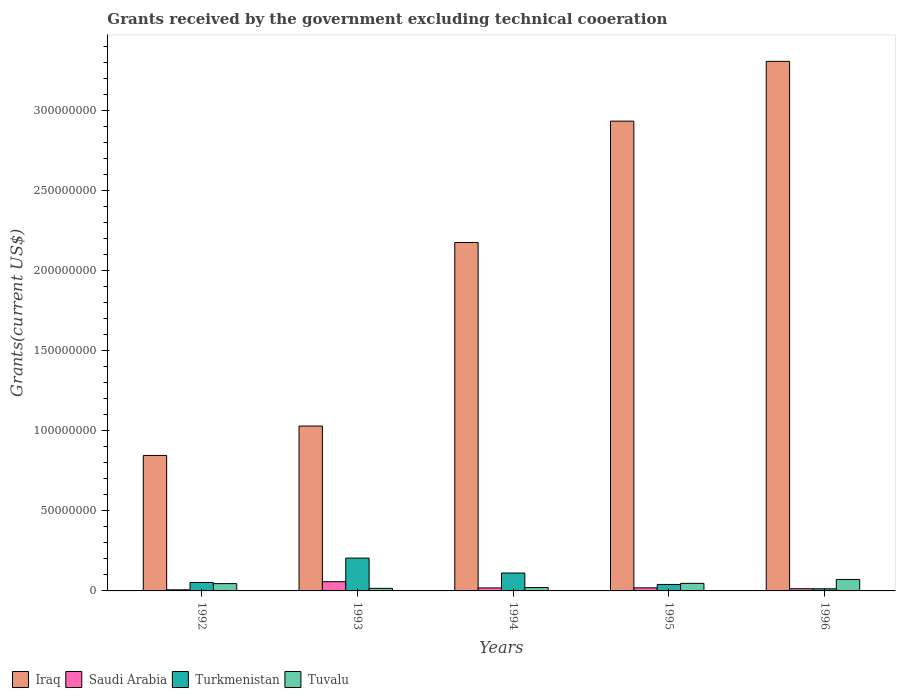Are the number of bars on each tick of the X-axis equal?
Provide a succinct answer. Yes. What is the label of the 1st group of bars from the left?
Your response must be concise. 1992. What is the total grants received by the government in Iraq in 1995?
Give a very brief answer. 2.94e+08. Across all years, what is the maximum total grants received by the government in Turkmenistan?
Offer a terse response. 2.05e+07. Across all years, what is the minimum total grants received by the government in Turkmenistan?
Your response must be concise. 1.32e+06. In which year was the total grants received by the government in Iraq minimum?
Provide a succinct answer. 1992. What is the total total grants received by the government in Saudi Arabia in the graph?
Offer a terse response. 1.16e+07. What is the difference between the total grants received by the government in Iraq in 1993 and that in 1995?
Provide a short and direct response. -1.91e+08. What is the difference between the total grants received by the government in Saudi Arabia in 1993 and the total grants received by the government in Iraq in 1995?
Provide a succinct answer. -2.88e+08. What is the average total grants received by the government in Tuvalu per year?
Your answer should be very brief. 4.03e+06. In the year 1995, what is the difference between the total grants received by the government in Tuvalu and total grants received by the government in Saudi Arabia?
Provide a succinct answer. 2.82e+06. What is the ratio of the total grants received by the government in Turkmenistan in 1992 to that in 1993?
Provide a short and direct response. 0.26. Is the total grants received by the government in Tuvalu in 1993 less than that in 1994?
Make the answer very short. Yes. What is the difference between the highest and the second highest total grants received by the government in Iraq?
Keep it short and to the point. 3.74e+07. What is the difference between the highest and the lowest total grants received by the government in Tuvalu?
Keep it short and to the point. 5.56e+06. In how many years, is the total grants received by the government in Tuvalu greater than the average total grants received by the government in Tuvalu taken over all years?
Your response must be concise. 3. Is the sum of the total grants received by the government in Tuvalu in 1995 and 1996 greater than the maximum total grants received by the government in Saudi Arabia across all years?
Your response must be concise. Yes. Is it the case that in every year, the sum of the total grants received by the government in Turkmenistan and total grants received by the government in Tuvalu is greater than the sum of total grants received by the government in Saudi Arabia and total grants received by the government in Iraq?
Give a very brief answer. Yes. What does the 4th bar from the left in 1996 represents?
Provide a succinct answer. Tuvalu. What does the 4th bar from the right in 1992 represents?
Offer a terse response. Iraq. Are all the bars in the graph horizontal?
Your answer should be compact. No. How many years are there in the graph?
Your answer should be very brief. 5. Are the values on the major ticks of Y-axis written in scientific E-notation?
Ensure brevity in your answer.  No. Does the graph contain grids?
Keep it short and to the point. No. Where does the legend appear in the graph?
Provide a succinct answer. Bottom left. What is the title of the graph?
Your answer should be very brief. Grants received by the government excluding technical cooeration. What is the label or title of the Y-axis?
Your answer should be very brief. Grants(current US$). What is the Grants(current US$) of Iraq in 1992?
Give a very brief answer. 8.47e+07. What is the Grants(current US$) of Saudi Arabia in 1992?
Your answer should be very brief. 6.90e+05. What is the Grants(current US$) of Turkmenistan in 1992?
Your answer should be very brief. 5.28e+06. What is the Grants(current US$) of Tuvalu in 1992?
Provide a short and direct response. 4.56e+06. What is the Grants(current US$) in Iraq in 1993?
Give a very brief answer. 1.03e+08. What is the Grants(current US$) of Saudi Arabia in 1993?
Your answer should be compact. 5.78e+06. What is the Grants(current US$) of Turkmenistan in 1993?
Provide a short and direct response. 2.05e+07. What is the Grants(current US$) in Tuvalu in 1993?
Give a very brief answer. 1.61e+06. What is the Grants(current US$) in Iraq in 1994?
Your answer should be very brief. 2.18e+08. What is the Grants(current US$) of Saudi Arabia in 1994?
Ensure brevity in your answer.  1.88e+06. What is the Grants(current US$) in Turkmenistan in 1994?
Your answer should be very brief. 1.12e+07. What is the Grants(current US$) of Tuvalu in 1994?
Your answer should be compact. 2.10e+06. What is the Grants(current US$) of Iraq in 1995?
Your response must be concise. 2.94e+08. What is the Grants(current US$) of Saudi Arabia in 1995?
Keep it short and to the point. 1.91e+06. What is the Grants(current US$) of Turkmenistan in 1995?
Offer a very short reply. 4.05e+06. What is the Grants(current US$) of Tuvalu in 1995?
Provide a short and direct response. 4.73e+06. What is the Grants(current US$) of Iraq in 1996?
Your answer should be very brief. 3.31e+08. What is the Grants(current US$) of Saudi Arabia in 1996?
Your answer should be compact. 1.36e+06. What is the Grants(current US$) in Turkmenistan in 1996?
Ensure brevity in your answer.  1.32e+06. What is the Grants(current US$) in Tuvalu in 1996?
Your answer should be very brief. 7.17e+06. Across all years, what is the maximum Grants(current US$) of Iraq?
Your response must be concise. 3.31e+08. Across all years, what is the maximum Grants(current US$) of Saudi Arabia?
Offer a very short reply. 5.78e+06. Across all years, what is the maximum Grants(current US$) in Turkmenistan?
Keep it short and to the point. 2.05e+07. Across all years, what is the maximum Grants(current US$) in Tuvalu?
Your response must be concise. 7.17e+06. Across all years, what is the minimum Grants(current US$) of Iraq?
Offer a very short reply. 8.47e+07. Across all years, what is the minimum Grants(current US$) of Saudi Arabia?
Provide a short and direct response. 6.90e+05. Across all years, what is the minimum Grants(current US$) in Turkmenistan?
Your answer should be very brief. 1.32e+06. Across all years, what is the minimum Grants(current US$) in Tuvalu?
Your answer should be very brief. 1.61e+06. What is the total Grants(current US$) in Iraq in the graph?
Your response must be concise. 1.03e+09. What is the total Grants(current US$) of Saudi Arabia in the graph?
Make the answer very short. 1.16e+07. What is the total Grants(current US$) of Turkmenistan in the graph?
Provide a short and direct response. 4.24e+07. What is the total Grants(current US$) in Tuvalu in the graph?
Offer a very short reply. 2.02e+07. What is the difference between the Grants(current US$) in Iraq in 1992 and that in 1993?
Your answer should be compact. -1.84e+07. What is the difference between the Grants(current US$) in Saudi Arabia in 1992 and that in 1993?
Ensure brevity in your answer.  -5.09e+06. What is the difference between the Grants(current US$) of Turkmenistan in 1992 and that in 1993?
Offer a very short reply. -1.52e+07. What is the difference between the Grants(current US$) of Tuvalu in 1992 and that in 1993?
Provide a succinct answer. 2.95e+06. What is the difference between the Grants(current US$) of Iraq in 1992 and that in 1994?
Your answer should be compact. -1.33e+08. What is the difference between the Grants(current US$) of Saudi Arabia in 1992 and that in 1994?
Keep it short and to the point. -1.19e+06. What is the difference between the Grants(current US$) in Turkmenistan in 1992 and that in 1994?
Your response must be concise. -5.91e+06. What is the difference between the Grants(current US$) of Tuvalu in 1992 and that in 1994?
Offer a very short reply. 2.46e+06. What is the difference between the Grants(current US$) in Iraq in 1992 and that in 1995?
Ensure brevity in your answer.  -2.09e+08. What is the difference between the Grants(current US$) in Saudi Arabia in 1992 and that in 1995?
Offer a terse response. -1.22e+06. What is the difference between the Grants(current US$) in Turkmenistan in 1992 and that in 1995?
Make the answer very short. 1.23e+06. What is the difference between the Grants(current US$) of Tuvalu in 1992 and that in 1995?
Offer a terse response. -1.70e+05. What is the difference between the Grants(current US$) in Iraq in 1992 and that in 1996?
Provide a short and direct response. -2.46e+08. What is the difference between the Grants(current US$) in Saudi Arabia in 1992 and that in 1996?
Your answer should be very brief. -6.70e+05. What is the difference between the Grants(current US$) of Turkmenistan in 1992 and that in 1996?
Keep it short and to the point. 3.96e+06. What is the difference between the Grants(current US$) in Tuvalu in 1992 and that in 1996?
Provide a succinct answer. -2.61e+06. What is the difference between the Grants(current US$) in Iraq in 1993 and that in 1994?
Make the answer very short. -1.15e+08. What is the difference between the Grants(current US$) of Saudi Arabia in 1993 and that in 1994?
Provide a short and direct response. 3.90e+06. What is the difference between the Grants(current US$) in Turkmenistan in 1993 and that in 1994?
Your answer should be very brief. 9.33e+06. What is the difference between the Grants(current US$) in Tuvalu in 1993 and that in 1994?
Provide a short and direct response. -4.90e+05. What is the difference between the Grants(current US$) of Iraq in 1993 and that in 1995?
Make the answer very short. -1.91e+08. What is the difference between the Grants(current US$) in Saudi Arabia in 1993 and that in 1995?
Provide a short and direct response. 3.87e+06. What is the difference between the Grants(current US$) of Turkmenistan in 1993 and that in 1995?
Make the answer very short. 1.65e+07. What is the difference between the Grants(current US$) in Tuvalu in 1993 and that in 1995?
Your answer should be very brief. -3.12e+06. What is the difference between the Grants(current US$) of Iraq in 1993 and that in 1996?
Offer a terse response. -2.28e+08. What is the difference between the Grants(current US$) of Saudi Arabia in 1993 and that in 1996?
Your answer should be very brief. 4.42e+06. What is the difference between the Grants(current US$) in Turkmenistan in 1993 and that in 1996?
Keep it short and to the point. 1.92e+07. What is the difference between the Grants(current US$) in Tuvalu in 1993 and that in 1996?
Provide a short and direct response. -5.56e+06. What is the difference between the Grants(current US$) in Iraq in 1994 and that in 1995?
Provide a short and direct response. -7.58e+07. What is the difference between the Grants(current US$) in Turkmenistan in 1994 and that in 1995?
Your answer should be very brief. 7.14e+06. What is the difference between the Grants(current US$) in Tuvalu in 1994 and that in 1995?
Ensure brevity in your answer.  -2.63e+06. What is the difference between the Grants(current US$) in Iraq in 1994 and that in 1996?
Ensure brevity in your answer.  -1.13e+08. What is the difference between the Grants(current US$) of Saudi Arabia in 1994 and that in 1996?
Make the answer very short. 5.20e+05. What is the difference between the Grants(current US$) of Turkmenistan in 1994 and that in 1996?
Your answer should be compact. 9.87e+06. What is the difference between the Grants(current US$) in Tuvalu in 1994 and that in 1996?
Make the answer very short. -5.07e+06. What is the difference between the Grants(current US$) in Iraq in 1995 and that in 1996?
Offer a very short reply. -3.74e+07. What is the difference between the Grants(current US$) in Saudi Arabia in 1995 and that in 1996?
Offer a terse response. 5.50e+05. What is the difference between the Grants(current US$) in Turkmenistan in 1995 and that in 1996?
Your answer should be very brief. 2.73e+06. What is the difference between the Grants(current US$) in Tuvalu in 1995 and that in 1996?
Your answer should be compact. -2.44e+06. What is the difference between the Grants(current US$) in Iraq in 1992 and the Grants(current US$) in Saudi Arabia in 1993?
Offer a very short reply. 7.89e+07. What is the difference between the Grants(current US$) of Iraq in 1992 and the Grants(current US$) of Turkmenistan in 1993?
Give a very brief answer. 6.42e+07. What is the difference between the Grants(current US$) of Iraq in 1992 and the Grants(current US$) of Tuvalu in 1993?
Your answer should be compact. 8.31e+07. What is the difference between the Grants(current US$) in Saudi Arabia in 1992 and the Grants(current US$) in Turkmenistan in 1993?
Provide a short and direct response. -1.98e+07. What is the difference between the Grants(current US$) of Saudi Arabia in 1992 and the Grants(current US$) of Tuvalu in 1993?
Your response must be concise. -9.20e+05. What is the difference between the Grants(current US$) of Turkmenistan in 1992 and the Grants(current US$) of Tuvalu in 1993?
Keep it short and to the point. 3.67e+06. What is the difference between the Grants(current US$) in Iraq in 1992 and the Grants(current US$) in Saudi Arabia in 1994?
Make the answer very short. 8.28e+07. What is the difference between the Grants(current US$) of Iraq in 1992 and the Grants(current US$) of Turkmenistan in 1994?
Ensure brevity in your answer.  7.35e+07. What is the difference between the Grants(current US$) of Iraq in 1992 and the Grants(current US$) of Tuvalu in 1994?
Offer a terse response. 8.26e+07. What is the difference between the Grants(current US$) of Saudi Arabia in 1992 and the Grants(current US$) of Turkmenistan in 1994?
Provide a short and direct response. -1.05e+07. What is the difference between the Grants(current US$) in Saudi Arabia in 1992 and the Grants(current US$) in Tuvalu in 1994?
Your response must be concise. -1.41e+06. What is the difference between the Grants(current US$) in Turkmenistan in 1992 and the Grants(current US$) in Tuvalu in 1994?
Ensure brevity in your answer.  3.18e+06. What is the difference between the Grants(current US$) of Iraq in 1992 and the Grants(current US$) of Saudi Arabia in 1995?
Provide a short and direct response. 8.28e+07. What is the difference between the Grants(current US$) in Iraq in 1992 and the Grants(current US$) in Turkmenistan in 1995?
Your answer should be very brief. 8.06e+07. What is the difference between the Grants(current US$) of Iraq in 1992 and the Grants(current US$) of Tuvalu in 1995?
Offer a terse response. 8.00e+07. What is the difference between the Grants(current US$) in Saudi Arabia in 1992 and the Grants(current US$) in Turkmenistan in 1995?
Your answer should be compact. -3.36e+06. What is the difference between the Grants(current US$) of Saudi Arabia in 1992 and the Grants(current US$) of Tuvalu in 1995?
Offer a terse response. -4.04e+06. What is the difference between the Grants(current US$) in Iraq in 1992 and the Grants(current US$) in Saudi Arabia in 1996?
Provide a succinct answer. 8.33e+07. What is the difference between the Grants(current US$) in Iraq in 1992 and the Grants(current US$) in Turkmenistan in 1996?
Provide a short and direct response. 8.34e+07. What is the difference between the Grants(current US$) of Iraq in 1992 and the Grants(current US$) of Tuvalu in 1996?
Offer a very short reply. 7.75e+07. What is the difference between the Grants(current US$) of Saudi Arabia in 1992 and the Grants(current US$) of Turkmenistan in 1996?
Offer a very short reply. -6.30e+05. What is the difference between the Grants(current US$) in Saudi Arabia in 1992 and the Grants(current US$) in Tuvalu in 1996?
Keep it short and to the point. -6.48e+06. What is the difference between the Grants(current US$) in Turkmenistan in 1992 and the Grants(current US$) in Tuvalu in 1996?
Offer a terse response. -1.89e+06. What is the difference between the Grants(current US$) in Iraq in 1993 and the Grants(current US$) in Saudi Arabia in 1994?
Provide a succinct answer. 1.01e+08. What is the difference between the Grants(current US$) of Iraq in 1993 and the Grants(current US$) of Turkmenistan in 1994?
Provide a succinct answer. 9.19e+07. What is the difference between the Grants(current US$) in Iraq in 1993 and the Grants(current US$) in Tuvalu in 1994?
Keep it short and to the point. 1.01e+08. What is the difference between the Grants(current US$) in Saudi Arabia in 1993 and the Grants(current US$) in Turkmenistan in 1994?
Your answer should be very brief. -5.41e+06. What is the difference between the Grants(current US$) in Saudi Arabia in 1993 and the Grants(current US$) in Tuvalu in 1994?
Ensure brevity in your answer.  3.68e+06. What is the difference between the Grants(current US$) in Turkmenistan in 1993 and the Grants(current US$) in Tuvalu in 1994?
Ensure brevity in your answer.  1.84e+07. What is the difference between the Grants(current US$) in Iraq in 1993 and the Grants(current US$) in Saudi Arabia in 1995?
Provide a succinct answer. 1.01e+08. What is the difference between the Grants(current US$) in Iraq in 1993 and the Grants(current US$) in Turkmenistan in 1995?
Your answer should be compact. 9.90e+07. What is the difference between the Grants(current US$) in Iraq in 1993 and the Grants(current US$) in Tuvalu in 1995?
Provide a succinct answer. 9.83e+07. What is the difference between the Grants(current US$) in Saudi Arabia in 1993 and the Grants(current US$) in Turkmenistan in 1995?
Offer a very short reply. 1.73e+06. What is the difference between the Grants(current US$) in Saudi Arabia in 1993 and the Grants(current US$) in Tuvalu in 1995?
Give a very brief answer. 1.05e+06. What is the difference between the Grants(current US$) of Turkmenistan in 1993 and the Grants(current US$) of Tuvalu in 1995?
Offer a very short reply. 1.58e+07. What is the difference between the Grants(current US$) in Iraq in 1993 and the Grants(current US$) in Saudi Arabia in 1996?
Make the answer very short. 1.02e+08. What is the difference between the Grants(current US$) of Iraq in 1993 and the Grants(current US$) of Turkmenistan in 1996?
Provide a short and direct response. 1.02e+08. What is the difference between the Grants(current US$) in Iraq in 1993 and the Grants(current US$) in Tuvalu in 1996?
Provide a succinct answer. 9.59e+07. What is the difference between the Grants(current US$) in Saudi Arabia in 1993 and the Grants(current US$) in Turkmenistan in 1996?
Provide a short and direct response. 4.46e+06. What is the difference between the Grants(current US$) of Saudi Arabia in 1993 and the Grants(current US$) of Tuvalu in 1996?
Your answer should be very brief. -1.39e+06. What is the difference between the Grants(current US$) of Turkmenistan in 1993 and the Grants(current US$) of Tuvalu in 1996?
Offer a terse response. 1.34e+07. What is the difference between the Grants(current US$) of Iraq in 1994 and the Grants(current US$) of Saudi Arabia in 1995?
Your answer should be very brief. 2.16e+08. What is the difference between the Grants(current US$) in Iraq in 1994 and the Grants(current US$) in Turkmenistan in 1995?
Your answer should be compact. 2.14e+08. What is the difference between the Grants(current US$) in Iraq in 1994 and the Grants(current US$) in Tuvalu in 1995?
Provide a succinct answer. 2.13e+08. What is the difference between the Grants(current US$) of Saudi Arabia in 1994 and the Grants(current US$) of Turkmenistan in 1995?
Make the answer very short. -2.17e+06. What is the difference between the Grants(current US$) in Saudi Arabia in 1994 and the Grants(current US$) in Tuvalu in 1995?
Provide a succinct answer. -2.85e+06. What is the difference between the Grants(current US$) of Turkmenistan in 1994 and the Grants(current US$) of Tuvalu in 1995?
Provide a short and direct response. 6.46e+06. What is the difference between the Grants(current US$) in Iraq in 1994 and the Grants(current US$) in Saudi Arabia in 1996?
Your response must be concise. 2.16e+08. What is the difference between the Grants(current US$) in Iraq in 1994 and the Grants(current US$) in Turkmenistan in 1996?
Your response must be concise. 2.16e+08. What is the difference between the Grants(current US$) in Iraq in 1994 and the Grants(current US$) in Tuvalu in 1996?
Offer a terse response. 2.11e+08. What is the difference between the Grants(current US$) of Saudi Arabia in 1994 and the Grants(current US$) of Turkmenistan in 1996?
Ensure brevity in your answer.  5.60e+05. What is the difference between the Grants(current US$) in Saudi Arabia in 1994 and the Grants(current US$) in Tuvalu in 1996?
Provide a short and direct response. -5.29e+06. What is the difference between the Grants(current US$) in Turkmenistan in 1994 and the Grants(current US$) in Tuvalu in 1996?
Offer a very short reply. 4.02e+06. What is the difference between the Grants(current US$) of Iraq in 1995 and the Grants(current US$) of Saudi Arabia in 1996?
Offer a terse response. 2.92e+08. What is the difference between the Grants(current US$) of Iraq in 1995 and the Grants(current US$) of Turkmenistan in 1996?
Make the answer very short. 2.92e+08. What is the difference between the Grants(current US$) of Iraq in 1995 and the Grants(current US$) of Tuvalu in 1996?
Your response must be concise. 2.86e+08. What is the difference between the Grants(current US$) of Saudi Arabia in 1995 and the Grants(current US$) of Turkmenistan in 1996?
Make the answer very short. 5.90e+05. What is the difference between the Grants(current US$) in Saudi Arabia in 1995 and the Grants(current US$) in Tuvalu in 1996?
Your answer should be compact. -5.26e+06. What is the difference between the Grants(current US$) of Turkmenistan in 1995 and the Grants(current US$) of Tuvalu in 1996?
Offer a very short reply. -3.12e+06. What is the average Grants(current US$) in Iraq per year?
Your response must be concise. 2.06e+08. What is the average Grants(current US$) in Saudi Arabia per year?
Make the answer very short. 2.32e+06. What is the average Grants(current US$) of Turkmenistan per year?
Offer a very short reply. 8.47e+06. What is the average Grants(current US$) of Tuvalu per year?
Make the answer very short. 4.03e+06. In the year 1992, what is the difference between the Grants(current US$) in Iraq and Grants(current US$) in Saudi Arabia?
Provide a short and direct response. 8.40e+07. In the year 1992, what is the difference between the Grants(current US$) of Iraq and Grants(current US$) of Turkmenistan?
Provide a short and direct response. 7.94e+07. In the year 1992, what is the difference between the Grants(current US$) of Iraq and Grants(current US$) of Tuvalu?
Your answer should be compact. 8.01e+07. In the year 1992, what is the difference between the Grants(current US$) in Saudi Arabia and Grants(current US$) in Turkmenistan?
Offer a terse response. -4.59e+06. In the year 1992, what is the difference between the Grants(current US$) in Saudi Arabia and Grants(current US$) in Tuvalu?
Your response must be concise. -3.87e+06. In the year 1992, what is the difference between the Grants(current US$) in Turkmenistan and Grants(current US$) in Tuvalu?
Offer a terse response. 7.20e+05. In the year 1993, what is the difference between the Grants(current US$) in Iraq and Grants(current US$) in Saudi Arabia?
Your answer should be compact. 9.73e+07. In the year 1993, what is the difference between the Grants(current US$) in Iraq and Grants(current US$) in Turkmenistan?
Keep it short and to the point. 8.25e+07. In the year 1993, what is the difference between the Grants(current US$) in Iraq and Grants(current US$) in Tuvalu?
Your response must be concise. 1.01e+08. In the year 1993, what is the difference between the Grants(current US$) of Saudi Arabia and Grants(current US$) of Turkmenistan?
Provide a succinct answer. -1.47e+07. In the year 1993, what is the difference between the Grants(current US$) in Saudi Arabia and Grants(current US$) in Tuvalu?
Offer a very short reply. 4.17e+06. In the year 1993, what is the difference between the Grants(current US$) in Turkmenistan and Grants(current US$) in Tuvalu?
Provide a short and direct response. 1.89e+07. In the year 1994, what is the difference between the Grants(current US$) in Iraq and Grants(current US$) in Saudi Arabia?
Keep it short and to the point. 2.16e+08. In the year 1994, what is the difference between the Grants(current US$) in Iraq and Grants(current US$) in Turkmenistan?
Provide a succinct answer. 2.07e+08. In the year 1994, what is the difference between the Grants(current US$) of Iraq and Grants(current US$) of Tuvalu?
Your response must be concise. 2.16e+08. In the year 1994, what is the difference between the Grants(current US$) in Saudi Arabia and Grants(current US$) in Turkmenistan?
Provide a succinct answer. -9.31e+06. In the year 1994, what is the difference between the Grants(current US$) of Saudi Arabia and Grants(current US$) of Tuvalu?
Your answer should be compact. -2.20e+05. In the year 1994, what is the difference between the Grants(current US$) in Turkmenistan and Grants(current US$) in Tuvalu?
Offer a very short reply. 9.09e+06. In the year 1995, what is the difference between the Grants(current US$) in Iraq and Grants(current US$) in Saudi Arabia?
Your answer should be very brief. 2.92e+08. In the year 1995, what is the difference between the Grants(current US$) in Iraq and Grants(current US$) in Turkmenistan?
Give a very brief answer. 2.90e+08. In the year 1995, what is the difference between the Grants(current US$) of Iraq and Grants(current US$) of Tuvalu?
Give a very brief answer. 2.89e+08. In the year 1995, what is the difference between the Grants(current US$) of Saudi Arabia and Grants(current US$) of Turkmenistan?
Your answer should be very brief. -2.14e+06. In the year 1995, what is the difference between the Grants(current US$) in Saudi Arabia and Grants(current US$) in Tuvalu?
Provide a succinct answer. -2.82e+06. In the year 1995, what is the difference between the Grants(current US$) of Turkmenistan and Grants(current US$) of Tuvalu?
Your response must be concise. -6.80e+05. In the year 1996, what is the difference between the Grants(current US$) of Iraq and Grants(current US$) of Saudi Arabia?
Offer a very short reply. 3.30e+08. In the year 1996, what is the difference between the Grants(current US$) of Iraq and Grants(current US$) of Turkmenistan?
Your answer should be very brief. 3.30e+08. In the year 1996, what is the difference between the Grants(current US$) of Iraq and Grants(current US$) of Tuvalu?
Offer a terse response. 3.24e+08. In the year 1996, what is the difference between the Grants(current US$) of Saudi Arabia and Grants(current US$) of Turkmenistan?
Your response must be concise. 4.00e+04. In the year 1996, what is the difference between the Grants(current US$) of Saudi Arabia and Grants(current US$) of Tuvalu?
Provide a succinct answer. -5.81e+06. In the year 1996, what is the difference between the Grants(current US$) in Turkmenistan and Grants(current US$) in Tuvalu?
Offer a very short reply. -5.85e+06. What is the ratio of the Grants(current US$) of Iraq in 1992 to that in 1993?
Your answer should be very brief. 0.82. What is the ratio of the Grants(current US$) in Saudi Arabia in 1992 to that in 1993?
Your answer should be compact. 0.12. What is the ratio of the Grants(current US$) in Turkmenistan in 1992 to that in 1993?
Keep it short and to the point. 0.26. What is the ratio of the Grants(current US$) of Tuvalu in 1992 to that in 1993?
Ensure brevity in your answer.  2.83. What is the ratio of the Grants(current US$) of Iraq in 1992 to that in 1994?
Ensure brevity in your answer.  0.39. What is the ratio of the Grants(current US$) of Saudi Arabia in 1992 to that in 1994?
Offer a very short reply. 0.37. What is the ratio of the Grants(current US$) of Turkmenistan in 1992 to that in 1994?
Give a very brief answer. 0.47. What is the ratio of the Grants(current US$) in Tuvalu in 1992 to that in 1994?
Your response must be concise. 2.17. What is the ratio of the Grants(current US$) of Iraq in 1992 to that in 1995?
Offer a very short reply. 0.29. What is the ratio of the Grants(current US$) of Saudi Arabia in 1992 to that in 1995?
Your answer should be very brief. 0.36. What is the ratio of the Grants(current US$) in Turkmenistan in 1992 to that in 1995?
Offer a terse response. 1.3. What is the ratio of the Grants(current US$) in Tuvalu in 1992 to that in 1995?
Offer a very short reply. 0.96. What is the ratio of the Grants(current US$) in Iraq in 1992 to that in 1996?
Offer a terse response. 0.26. What is the ratio of the Grants(current US$) of Saudi Arabia in 1992 to that in 1996?
Your response must be concise. 0.51. What is the ratio of the Grants(current US$) of Turkmenistan in 1992 to that in 1996?
Provide a succinct answer. 4. What is the ratio of the Grants(current US$) of Tuvalu in 1992 to that in 1996?
Provide a short and direct response. 0.64. What is the ratio of the Grants(current US$) of Iraq in 1993 to that in 1994?
Ensure brevity in your answer.  0.47. What is the ratio of the Grants(current US$) in Saudi Arabia in 1993 to that in 1994?
Keep it short and to the point. 3.07. What is the ratio of the Grants(current US$) in Turkmenistan in 1993 to that in 1994?
Your response must be concise. 1.83. What is the ratio of the Grants(current US$) in Tuvalu in 1993 to that in 1994?
Ensure brevity in your answer.  0.77. What is the ratio of the Grants(current US$) of Iraq in 1993 to that in 1995?
Make the answer very short. 0.35. What is the ratio of the Grants(current US$) of Saudi Arabia in 1993 to that in 1995?
Ensure brevity in your answer.  3.03. What is the ratio of the Grants(current US$) in Turkmenistan in 1993 to that in 1995?
Give a very brief answer. 5.07. What is the ratio of the Grants(current US$) in Tuvalu in 1993 to that in 1995?
Offer a terse response. 0.34. What is the ratio of the Grants(current US$) in Iraq in 1993 to that in 1996?
Offer a terse response. 0.31. What is the ratio of the Grants(current US$) of Saudi Arabia in 1993 to that in 1996?
Your response must be concise. 4.25. What is the ratio of the Grants(current US$) in Turkmenistan in 1993 to that in 1996?
Provide a short and direct response. 15.55. What is the ratio of the Grants(current US$) in Tuvalu in 1993 to that in 1996?
Provide a succinct answer. 0.22. What is the ratio of the Grants(current US$) in Iraq in 1994 to that in 1995?
Provide a short and direct response. 0.74. What is the ratio of the Grants(current US$) in Saudi Arabia in 1994 to that in 1995?
Ensure brevity in your answer.  0.98. What is the ratio of the Grants(current US$) in Turkmenistan in 1994 to that in 1995?
Your answer should be very brief. 2.76. What is the ratio of the Grants(current US$) in Tuvalu in 1994 to that in 1995?
Your answer should be very brief. 0.44. What is the ratio of the Grants(current US$) in Iraq in 1994 to that in 1996?
Keep it short and to the point. 0.66. What is the ratio of the Grants(current US$) of Saudi Arabia in 1994 to that in 1996?
Your answer should be compact. 1.38. What is the ratio of the Grants(current US$) of Turkmenistan in 1994 to that in 1996?
Your response must be concise. 8.48. What is the ratio of the Grants(current US$) of Tuvalu in 1994 to that in 1996?
Your answer should be compact. 0.29. What is the ratio of the Grants(current US$) in Iraq in 1995 to that in 1996?
Make the answer very short. 0.89. What is the ratio of the Grants(current US$) in Saudi Arabia in 1995 to that in 1996?
Ensure brevity in your answer.  1.4. What is the ratio of the Grants(current US$) of Turkmenistan in 1995 to that in 1996?
Offer a very short reply. 3.07. What is the ratio of the Grants(current US$) in Tuvalu in 1995 to that in 1996?
Your response must be concise. 0.66. What is the difference between the highest and the second highest Grants(current US$) in Iraq?
Provide a short and direct response. 3.74e+07. What is the difference between the highest and the second highest Grants(current US$) in Saudi Arabia?
Give a very brief answer. 3.87e+06. What is the difference between the highest and the second highest Grants(current US$) in Turkmenistan?
Offer a terse response. 9.33e+06. What is the difference between the highest and the second highest Grants(current US$) of Tuvalu?
Ensure brevity in your answer.  2.44e+06. What is the difference between the highest and the lowest Grants(current US$) of Iraq?
Make the answer very short. 2.46e+08. What is the difference between the highest and the lowest Grants(current US$) in Saudi Arabia?
Your answer should be compact. 5.09e+06. What is the difference between the highest and the lowest Grants(current US$) of Turkmenistan?
Ensure brevity in your answer.  1.92e+07. What is the difference between the highest and the lowest Grants(current US$) in Tuvalu?
Your response must be concise. 5.56e+06. 